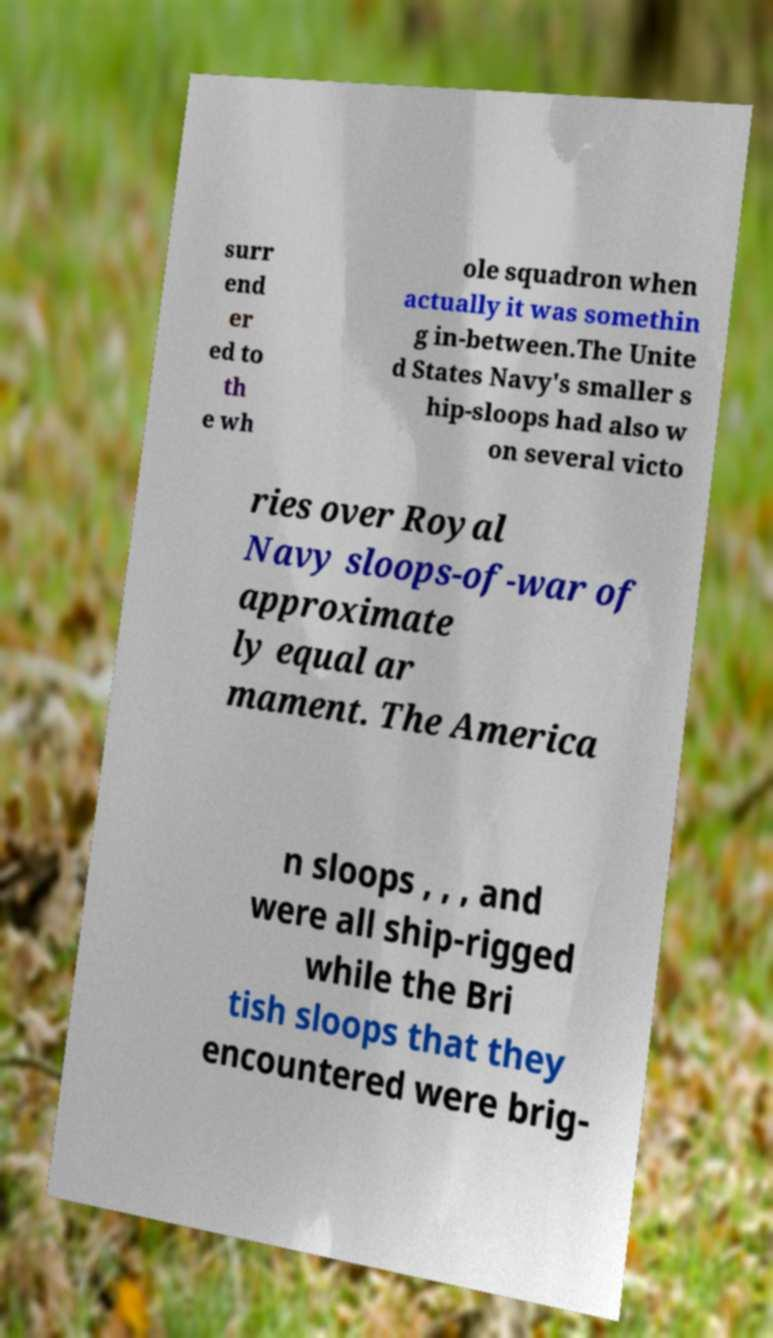Could you extract and type out the text from this image? surr end er ed to th e wh ole squadron when actually it was somethin g in-between.The Unite d States Navy's smaller s hip-sloops had also w on several victo ries over Royal Navy sloops-of-war of approximate ly equal ar mament. The America n sloops , , , and were all ship-rigged while the Bri tish sloops that they encountered were brig- 